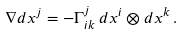<formula> <loc_0><loc_0><loc_500><loc_500>\nabla d x ^ { j } = - \Gamma _ { i k } ^ { j } \, d x ^ { i } \otimes d x ^ { k } \, .</formula> 